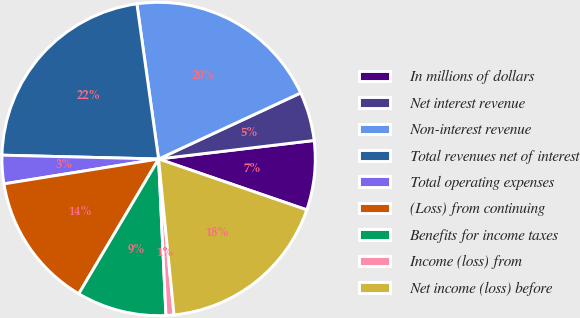<chart> <loc_0><loc_0><loc_500><loc_500><pie_chart><fcel>In millions of dollars<fcel>Net interest revenue<fcel>Non-interest revenue<fcel>Total revenues net of interest<fcel>Total operating expenses<fcel>(Loss) from continuing<fcel>Benefits for income taxes<fcel>Income (loss) from<fcel>Net income (loss) before<nl><fcel>7.15%<fcel>5.04%<fcel>20.29%<fcel>22.4%<fcel>2.93%<fcel>13.95%<fcel>9.26%<fcel>0.82%<fcel>18.17%<nl></chart> 